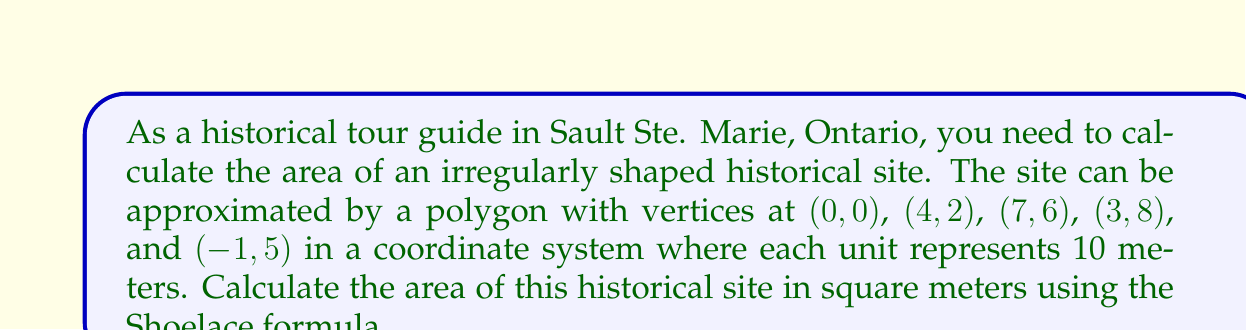Help me with this question. To solve this problem, we'll use the Shoelace formula (also known as the surveyor's formula) for calculating the area of a polygon given its vertices. The formula is:

$$ A = \frac{1}{2} \left| \sum_{i=1}^{n} (x_i y_{i+1} - x_{i+1} y_i) \right| $$

Where $(x_i, y_i)$ are the coordinates of the $i$-th vertex, and $(x_{n+1}, y_{n+1}) = (x_1, y_1)$.

Step 1: List the vertices in order:
$(x_1, y_1) = (0, 0)$
$(x_2, y_2) = (4, 2)$
$(x_3, y_3) = (7, 6)$
$(x_4, y_4) = (3, 8)$
$(x_5, y_5) = (-1, 5)$

Step 2: Apply the Shoelace formula:

$A = \frac{1}{2} |(0 \cdot 2 + 4 \cdot 6 + 7 \cdot 8 + 3 \cdot 5 + (-1) \cdot 0) - (4 \cdot 0 + 7 \cdot 2 + 3 \cdot 6 + (-1) \cdot 8 + 0 \cdot 5)|$

$A = \frac{1}{2} |(0 + 24 + 56 + 15 + 0) - (0 + 14 + 18 - 8 + 0)|$

$A = \frac{1}{2} |95 - 24|$

$A = \frac{1}{2} \cdot 71 = 35.5$

Step 3: Convert the result to square meters:
Since each unit represents 10 meters, we need to multiply the area by $10^2 = 100$:

$\text{Area in square meters} = 35.5 \cdot 100 = 3550$

Therefore, the area of the historical site is 3550 square meters.
Answer: 3550 m² 